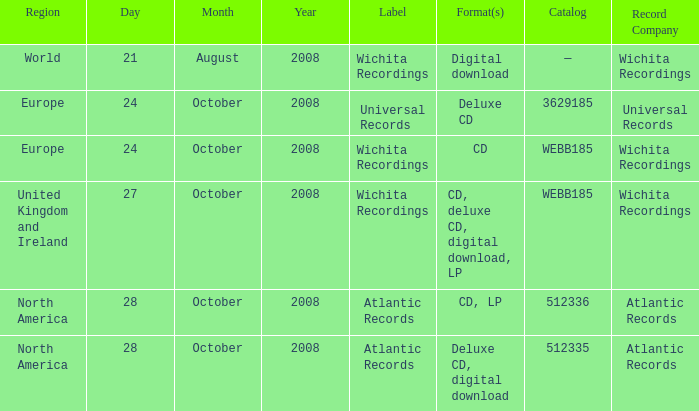Which date was associated with the release in Europe on the Wichita Recordings label? 24 October 2008. 